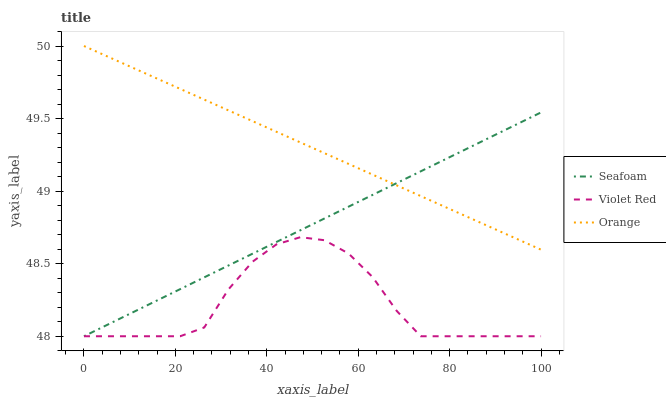Does Violet Red have the minimum area under the curve?
Answer yes or no. Yes. Does Orange have the maximum area under the curve?
Answer yes or no. Yes. Does Seafoam have the minimum area under the curve?
Answer yes or no. No. Does Seafoam have the maximum area under the curve?
Answer yes or no. No. Is Orange the smoothest?
Answer yes or no. Yes. Is Violet Red the roughest?
Answer yes or no. Yes. Is Seafoam the smoothest?
Answer yes or no. No. Is Seafoam the roughest?
Answer yes or no. No. Does Violet Red have the lowest value?
Answer yes or no. Yes. Does Orange have the highest value?
Answer yes or no. Yes. Does Seafoam have the highest value?
Answer yes or no. No. Is Violet Red less than Orange?
Answer yes or no. Yes. Is Orange greater than Violet Red?
Answer yes or no. Yes. Does Orange intersect Seafoam?
Answer yes or no. Yes. Is Orange less than Seafoam?
Answer yes or no. No. Is Orange greater than Seafoam?
Answer yes or no. No. Does Violet Red intersect Orange?
Answer yes or no. No. 